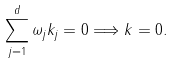<formula> <loc_0><loc_0><loc_500><loc_500>\sum _ { j = 1 } ^ { d } \omega _ { j } k _ { j } = 0 \Longrightarrow k = 0 .</formula> 